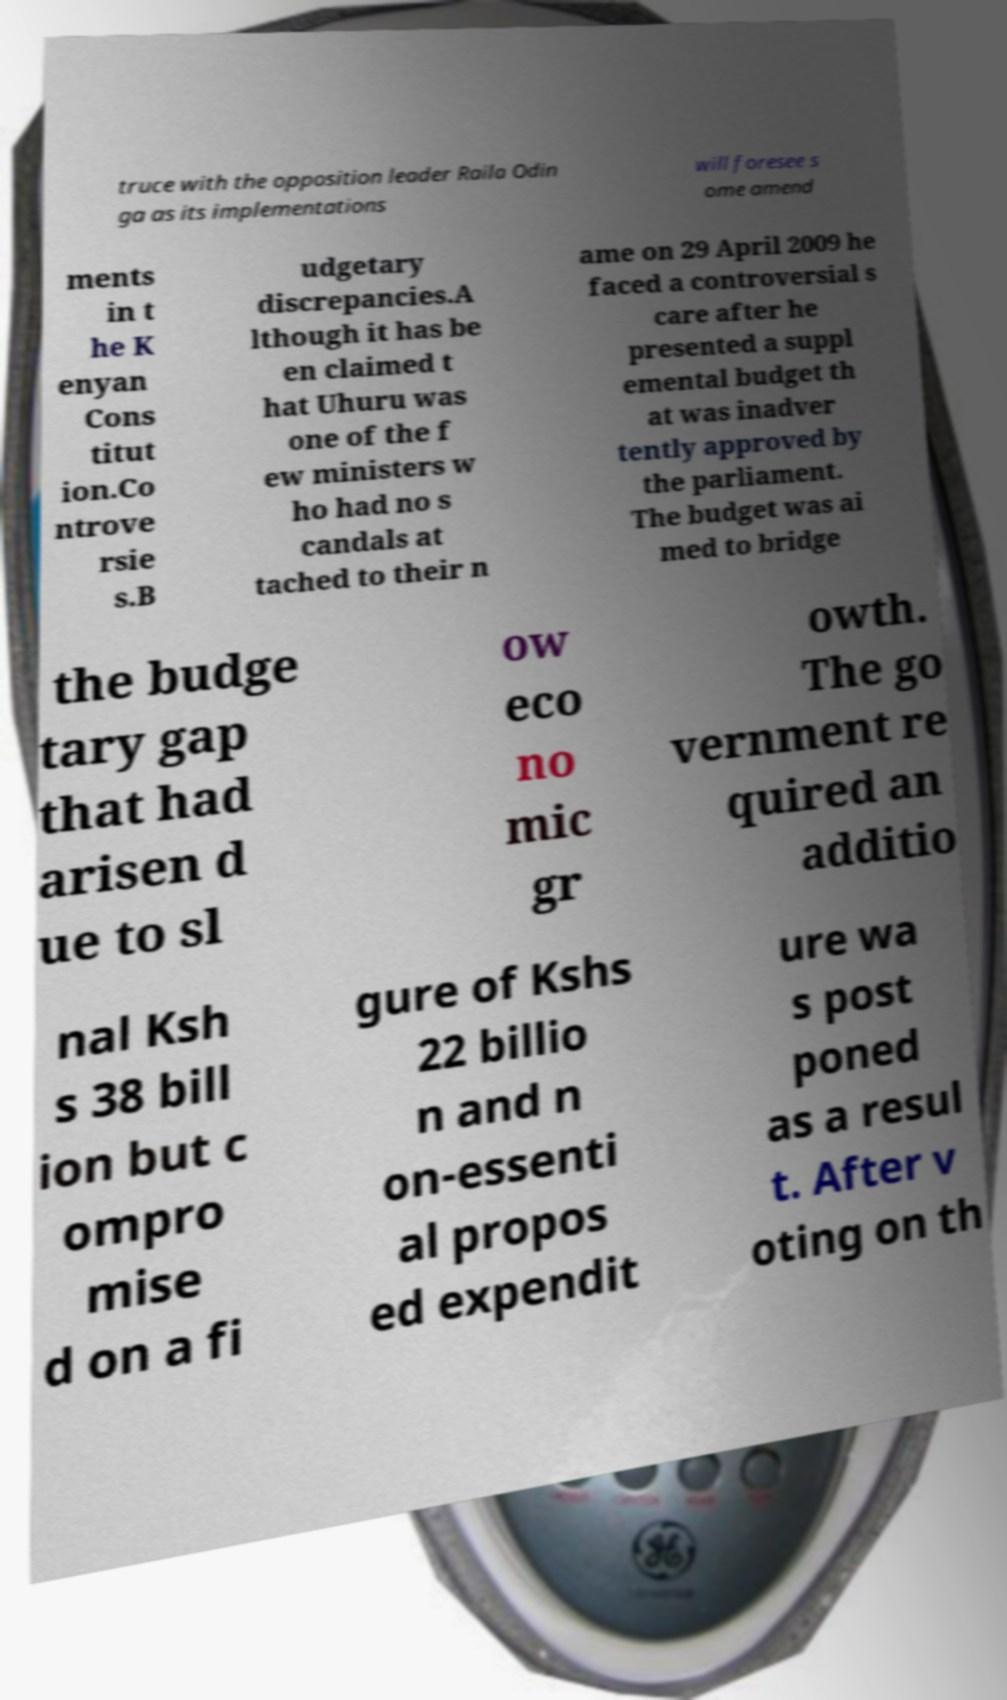There's text embedded in this image that I need extracted. Can you transcribe it verbatim? truce with the opposition leader Raila Odin ga as its implementations will foresee s ome amend ments in t he K enyan Cons titut ion.Co ntrove rsie s.B udgetary discrepancies.A lthough it has be en claimed t hat Uhuru was one of the f ew ministers w ho had no s candals at tached to their n ame on 29 April 2009 he faced a controversial s care after he presented a suppl emental budget th at was inadver tently approved by the parliament. The budget was ai med to bridge the budge tary gap that had arisen d ue to sl ow eco no mic gr owth. The go vernment re quired an additio nal Ksh s 38 bill ion but c ompro mise d on a fi gure of Kshs 22 billio n and n on-essenti al propos ed expendit ure wa s post poned as a resul t. After v oting on th 